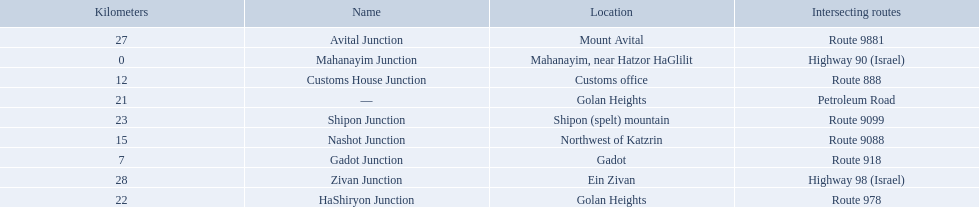Which junctions cross a route? Gadot Junction, Customs House Junction, Nashot Junction, HaShiryon Junction, Shipon Junction, Avital Junction. Which of these shares [art of its name with its locations name? Gadot Junction, Customs House Junction, Shipon Junction, Avital Junction. Which of them is not located in a locations named after a mountain? Gadot Junction, Customs House Junction. Which of these has the highest route number? Gadot Junction. 